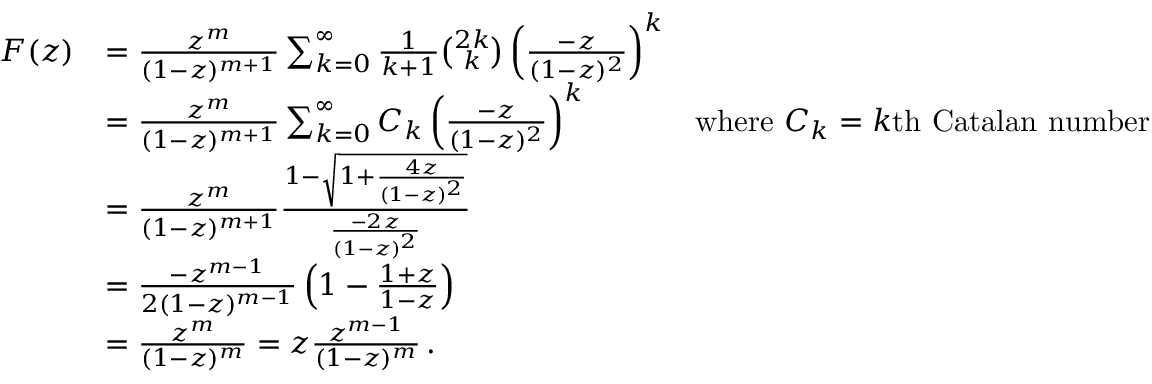Convert formula to latex. <formula><loc_0><loc_0><loc_500><loc_500>{ \begin{array} { r l r } { F ( z ) } & { = { \frac { z ^ { m } } { ( 1 - z ) ^ { m + 1 } } } \sum _ { k = 0 } ^ { \infty } { { \frac { 1 } { k + 1 } } { \binom { 2 k } { k } } \left ( { \frac { - z } { ( 1 - z ) ^ { 2 } } } \right ) ^ { k } } } \\ & { = { \frac { z ^ { m } } { ( 1 - z ) ^ { m + 1 } } } \sum _ { k = 0 } ^ { \infty } { C _ { k } \left ( { \frac { - z } { ( 1 - z ) ^ { 2 } } } \right ) ^ { k } } } & { { w h e r e } C _ { k } = k { t h C a t a l a n n u m b e r } } \\ & { = { \frac { z ^ { m } } { ( 1 - z ) ^ { m + 1 } } } { \frac { 1 - { \sqrt { 1 + { \frac { 4 z } { ( 1 - z ) ^ { 2 } } } } } } { \frac { - 2 z } { ( 1 - z ) ^ { 2 } } } } } \\ & { = { \frac { - z ^ { m - 1 } } { 2 ( 1 - z ) ^ { m - 1 } } } \left ( 1 - { \frac { 1 + z } { 1 - z } } \right ) } \\ & { = { \frac { z ^ { m } } { ( 1 - z ) ^ { m } } } = z { \frac { z ^ { m - 1 } } { ( 1 - z ) ^ { m } } } \, . } \end{array} }</formula> 